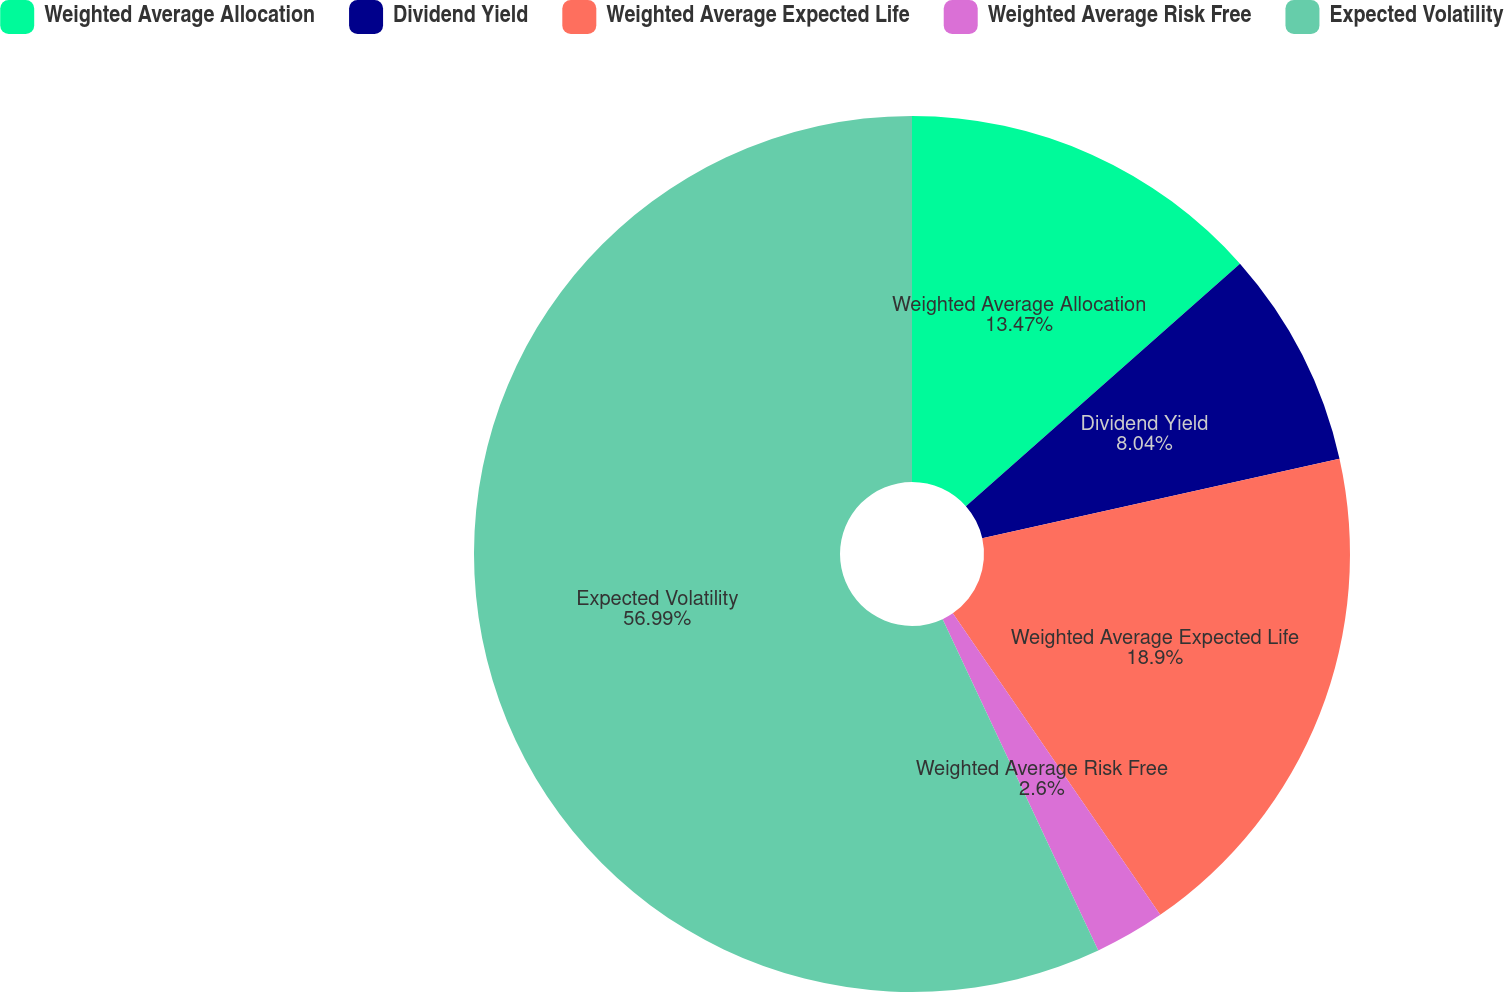Convert chart. <chart><loc_0><loc_0><loc_500><loc_500><pie_chart><fcel>Weighted Average Allocation<fcel>Dividend Yield<fcel>Weighted Average Expected Life<fcel>Weighted Average Risk Free<fcel>Expected Volatility<nl><fcel>13.47%<fcel>8.04%<fcel>18.9%<fcel>2.6%<fcel>56.99%<nl></chart> 